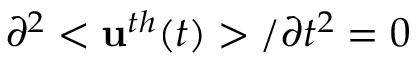<formula> <loc_0><loc_0><loc_500><loc_500>\partial ^ { 2 } < u ^ { t h } ( t ) > / \partial t ^ { 2 } = 0</formula> 